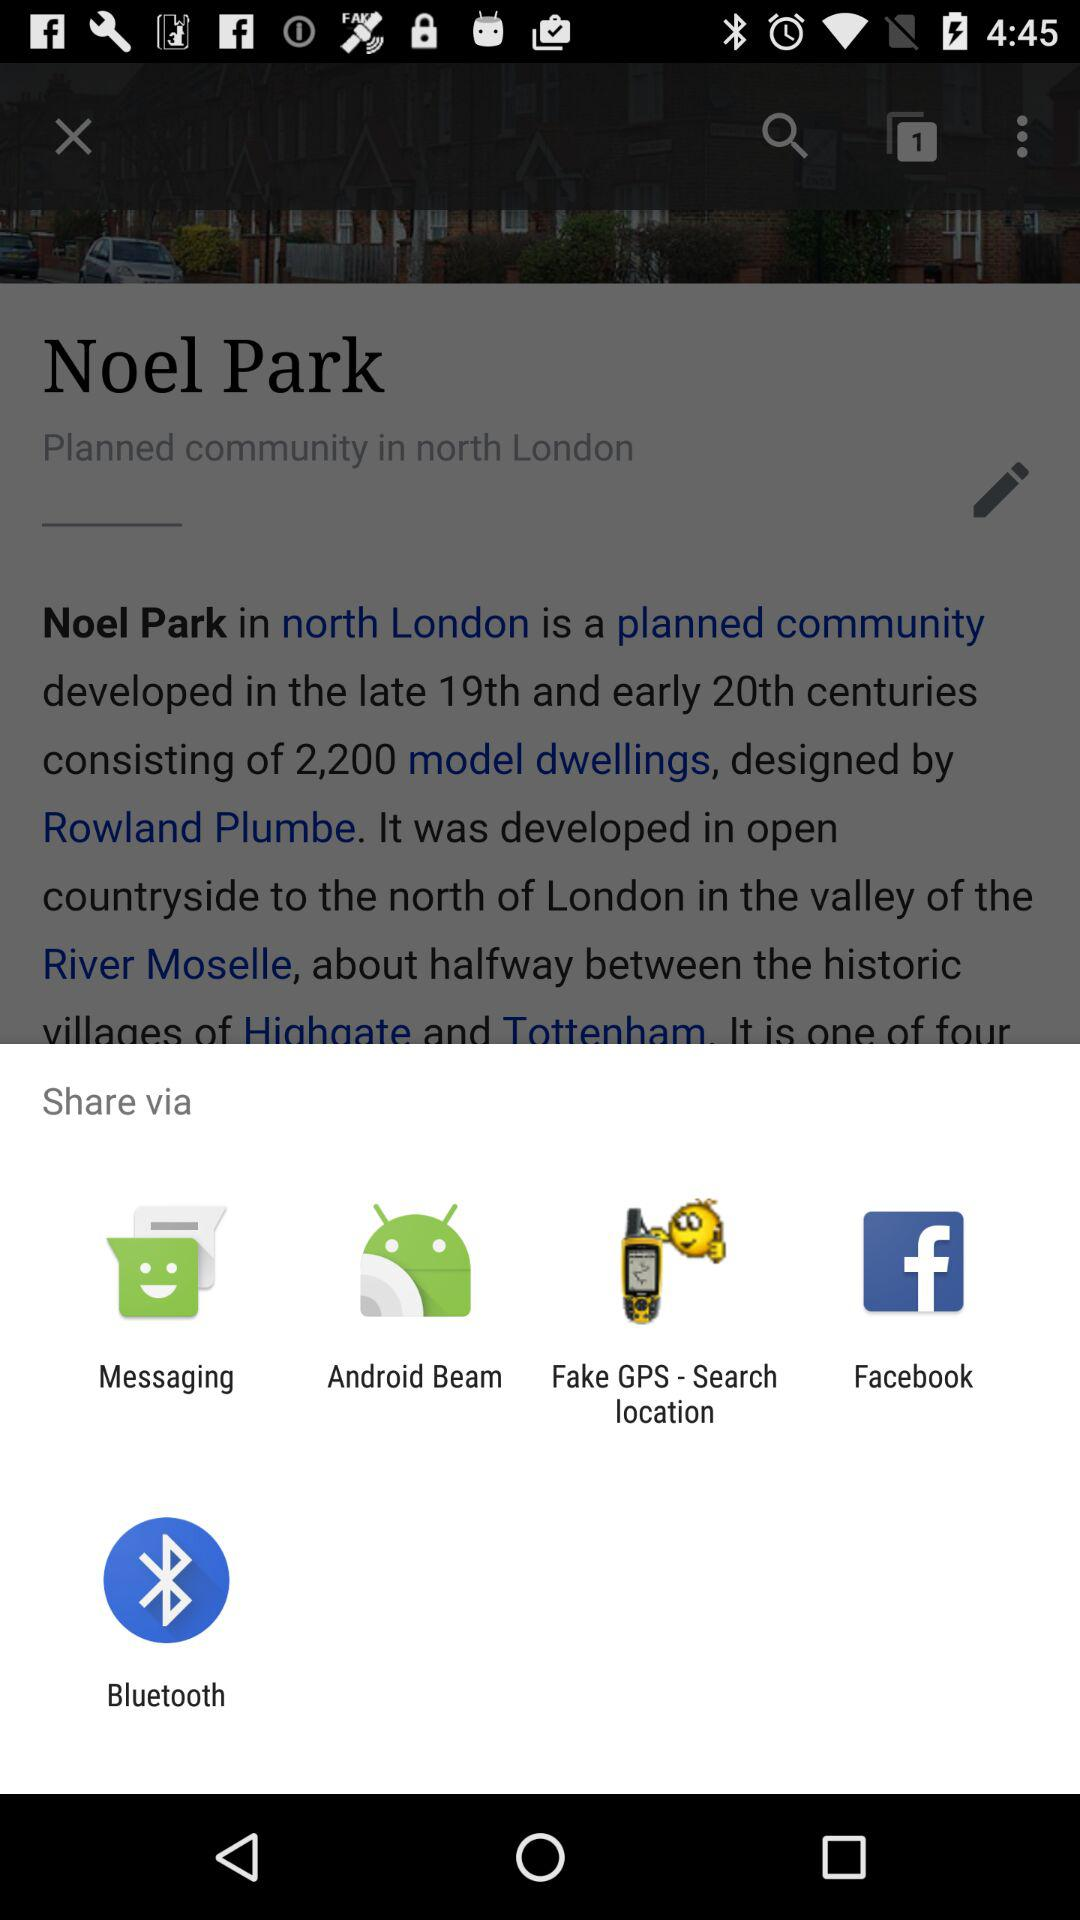What is the planned community in North London? The planned community in North London is Noel Park. 